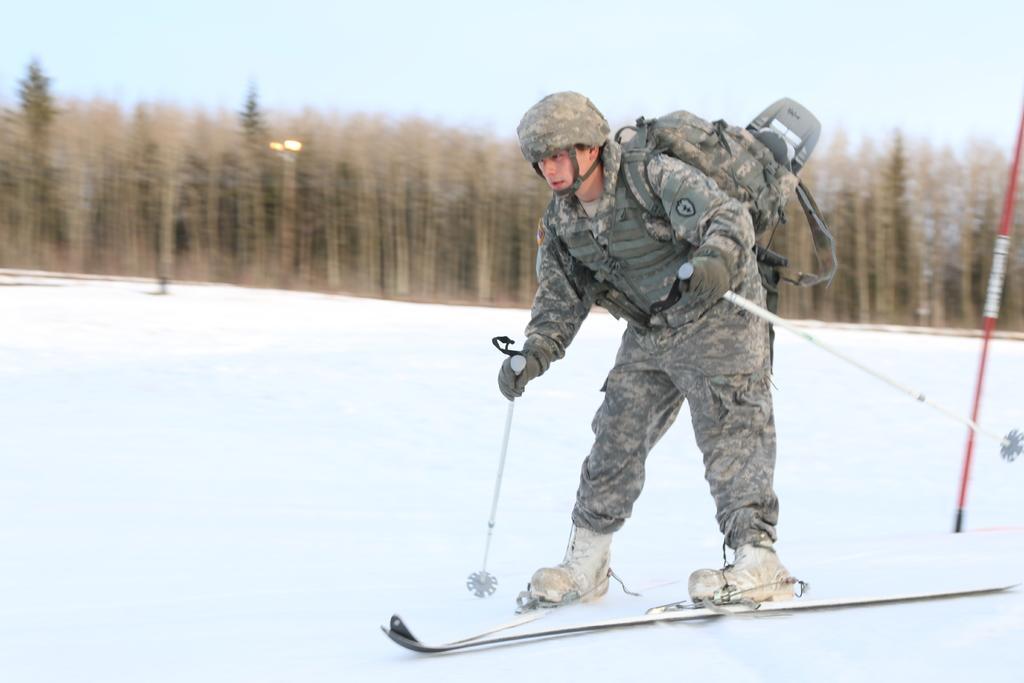How would you summarize this image in a sentence or two? In this image we can see one man in army dress with helmet wearing a bag, holding two sticks and skiing on the snow. There is one red pole, one object in the snow, two lights, ground is full of snow, some trees in the background and at the top there is the sky. 